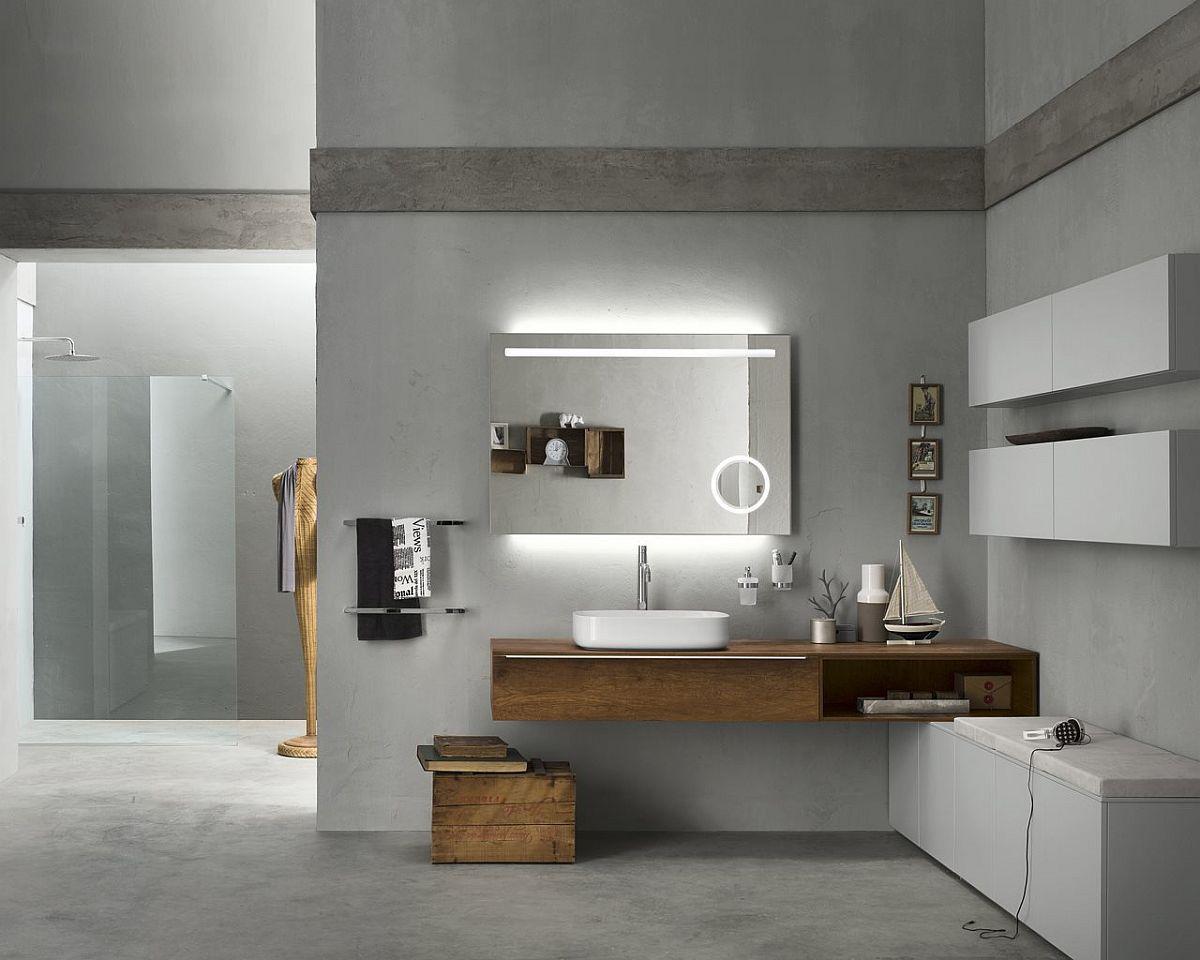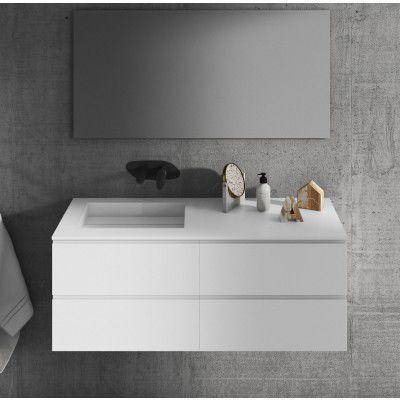The first image is the image on the left, the second image is the image on the right. Given the left and right images, does the statement "IN at least one image there is a single raised basin on top of a floating cabinet shelf." hold true? Answer yes or no. Yes. The first image is the image on the left, the second image is the image on the right. Considering the images on both sides, is "One of the sinks is a bowl type." valid? Answer yes or no. Yes. 